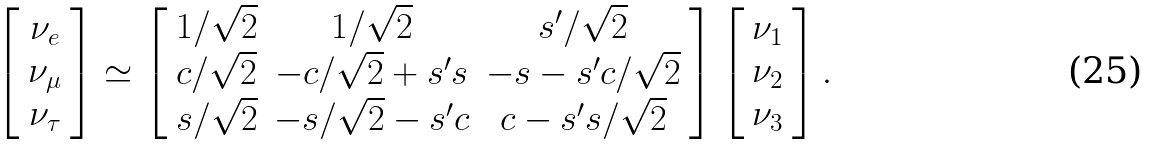<formula> <loc_0><loc_0><loc_500><loc_500>\left [ \begin{array} { c } { { \nu _ { e } } } \\ { { \nu _ { \mu } } } \\ { { \nu _ { \tau } } } \end{array} \right ] \simeq \left [ \begin{array} { c c c } { 1 / \sqrt { 2 } } & { 1 / \sqrt { 2 } } & { { s ^ { \prime } / \sqrt { 2 } } } \\ { c / \sqrt { 2 } } & { { - c / \sqrt { 2 } + s ^ { \prime } s } } & { { - s - s ^ { \prime } c / \sqrt { 2 } } } \\ { s / \sqrt { 2 } } & { { - s / \sqrt { 2 } - s ^ { \prime } c } } & { { c - s ^ { \prime } s / \sqrt { 2 } } } \end{array} \right ] \left [ \begin{array} { c } { { \nu _ { 1 } } } \\ { { \nu _ { 2 } } } \\ { { \nu _ { 3 } } } \end{array} \right ] .</formula> 